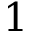Convert formula to latex. <formula><loc_0><loc_0><loc_500><loc_500>1</formula> 